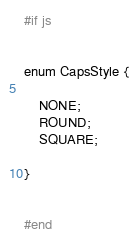<code> <loc_0><loc_0><loc_500><loc_500><_Haxe_>#if js


enum CapsStyle {
	
	NONE;
	ROUND;
	SQUARE;
	
}


#end</code> 